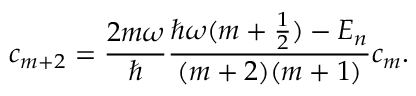<formula> <loc_0><loc_0><loc_500><loc_500>c _ { m + 2 } = \frac { 2 m \omega } { } \frac { \hbar { \omega } ( m + \frac { 1 } { 2 } ) - E _ { n } } { ( m + 2 ) ( m + 1 ) } c _ { m } .</formula> 